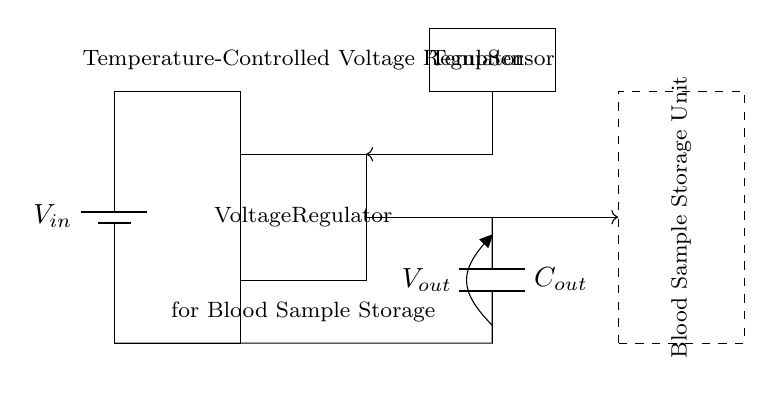What is the input voltage of this circuit? The input voltage is represented as V in the circuit diagram. It indicates the voltage supply connected to the regulator.
Answer: V in What component controls the output voltage? The component that controls the output voltage is the voltage regulator. It takes the input voltage and regulates it to a specified output voltage.
Answer: Voltage Regulator What is the purpose of the temperature sensor? The temperature sensor measures the temperature and provides feedback to the regulator, allowing for adjustments in the output voltage based on temperature readings to ensure proper thermal management.
Answer: Thermal management Which component stores the regulated output voltage? The output capacitor, denoted as C out in the diagram, stores the regulated output voltage and acts as a filter to smooth out any voltage fluctuations.
Answer: C out What is the output voltage's destination in the circuit? The output voltage is directed towards the blood sample storage unit, ensuring that the unit operates within the desired temperature range as indicated by the feedback from the temperature sensor.
Answer: Blood Sample Storage Unit How does the feedback loop influence the circuit operation? The feedback loop connects the temperature sensor's output to the voltage regulator, allowing the regulator to adjust its output based on real-time temperature data, thereby maintaining stable thermal conditions for the blood samples.
Answer: Stabilizes output What indicates that this circuit is designed for thermal management? The presence of both a temperature sensor and a feedback loop illustrates that the circuit is designed specifically for thermal management, allowing for precise control over the temperature of the blood sample storage unit.
Answer: Temperature control 